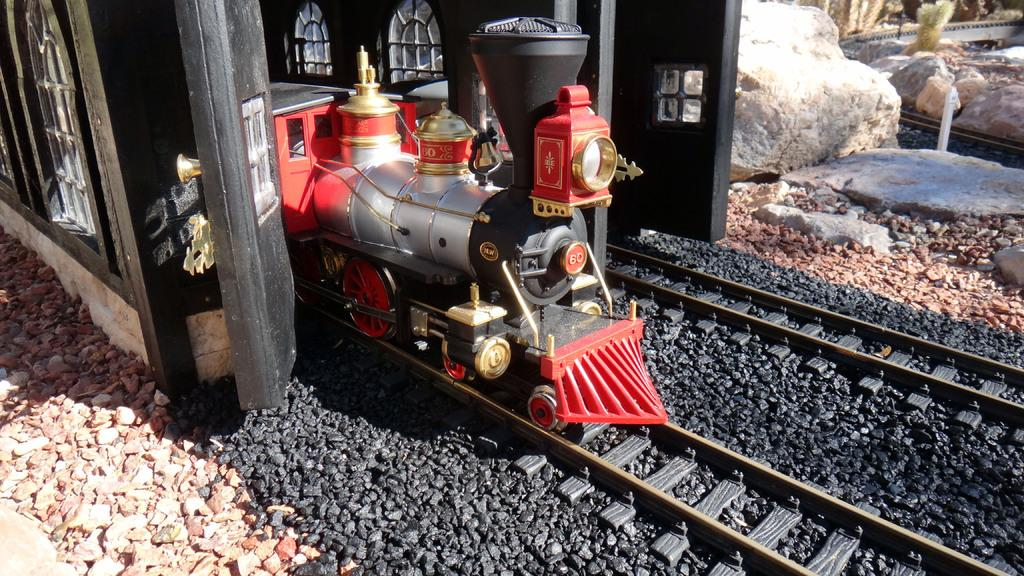What is the main subject of the picture? The main subject of the picture is a toy train. What else can be seen in the picture besides the toy train? There is a building with windows and a train moving on a track in the picture. Can you describe the building in the picture? The building has windows. What is present on the sides of the image? There are rocks on the left and right sides of the image. What type of pot can be seen in the image? There is no pot present in the image. How many ducks are visible in the image? There are no ducks present in the image. 